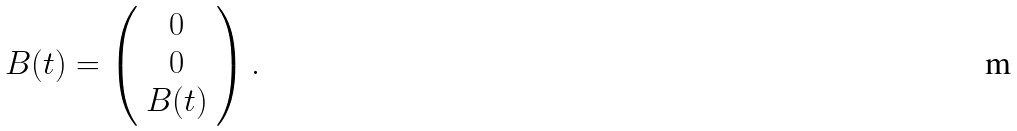Convert formula to latex. <formula><loc_0><loc_0><loc_500><loc_500>B ( t ) = \left ( \begin{array} { c } 0 \\ 0 \\ B ( t ) \end{array} \right ) .</formula> 